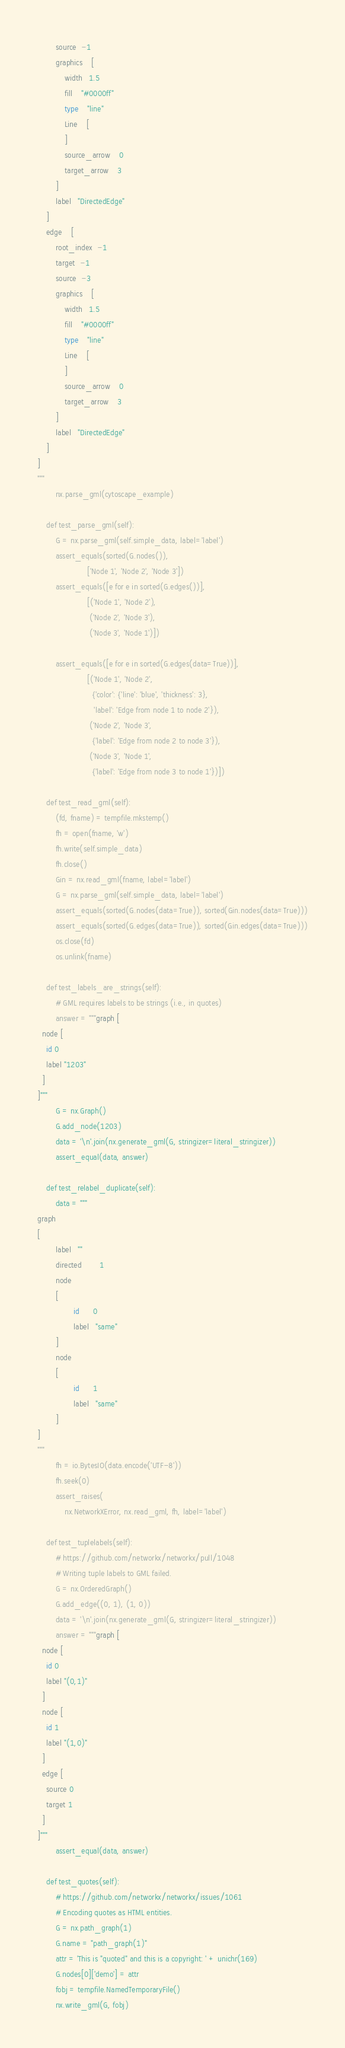<code> <loc_0><loc_0><loc_500><loc_500><_Python_>        source  -1
        graphics    [
            width   1.5
            fill    "#0000ff"
            type    "line"
            Line    [
            ]
            source_arrow    0
            target_arrow    3
        ]
        label   "DirectedEdge"
    ]
    edge    [
        root_index  -1
        target  -1
        source  -3
        graphics    [
            width   1.5
            fill    "#0000ff"
            type    "line"
            Line    [
            ]
            source_arrow    0
            target_arrow    3
        ]
        label   "DirectedEdge"
    ]
]
"""
        nx.parse_gml(cytoscape_example)

    def test_parse_gml(self):
        G = nx.parse_gml(self.simple_data, label='label')
        assert_equals(sorted(G.nodes()),
                      ['Node 1', 'Node 2', 'Node 3'])
        assert_equals([e for e in sorted(G.edges())],
                      [('Node 1', 'Node 2'),
                       ('Node 2', 'Node 3'),
                       ('Node 3', 'Node 1')])

        assert_equals([e for e in sorted(G.edges(data=True))],
                      [('Node 1', 'Node 2',
                        {'color': {'line': 'blue', 'thickness': 3},
                         'label': 'Edge from node 1 to node 2'}),
                       ('Node 2', 'Node 3',
                        {'label': 'Edge from node 2 to node 3'}),
                       ('Node 3', 'Node 1',
                        {'label': 'Edge from node 3 to node 1'})])

    def test_read_gml(self):
        (fd, fname) = tempfile.mkstemp()
        fh = open(fname, 'w')
        fh.write(self.simple_data)
        fh.close()
        Gin = nx.read_gml(fname, label='label')
        G = nx.parse_gml(self.simple_data, label='label')
        assert_equals(sorted(G.nodes(data=True)), sorted(Gin.nodes(data=True)))
        assert_equals(sorted(G.edges(data=True)), sorted(Gin.edges(data=True)))
        os.close(fd)
        os.unlink(fname)

    def test_labels_are_strings(self):
        # GML requires labels to be strings (i.e., in quotes)
        answer = """graph [
  node [
    id 0
    label "1203"
  ]
]"""
        G = nx.Graph()
        G.add_node(1203)
        data = '\n'.join(nx.generate_gml(G, stringizer=literal_stringizer))
        assert_equal(data, answer)

    def test_relabel_duplicate(self):
        data = """
graph
[
        label   ""
        directed        1
        node
        [
                id      0
                label   "same"
        ]
        node
        [
                id      1
                label   "same"
        ]
]
"""
        fh = io.BytesIO(data.encode('UTF-8'))
        fh.seek(0)
        assert_raises(
            nx.NetworkXError, nx.read_gml, fh, label='label')

    def test_tuplelabels(self):
        # https://github.com/networkx/networkx/pull/1048
        # Writing tuple labels to GML failed.
        G = nx.OrderedGraph()
        G.add_edge((0, 1), (1, 0))
        data = '\n'.join(nx.generate_gml(G, stringizer=literal_stringizer))
        answer = """graph [
  node [
    id 0
    label "(0,1)"
  ]
  node [
    id 1
    label "(1,0)"
  ]
  edge [
    source 0
    target 1
  ]
]"""
        assert_equal(data, answer)

    def test_quotes(self):
        # https://github.com/networkx/networkx/issues/1061
        # Encoding quotes as HTML entities.
        G = nx.path_graph(1)
        G.name = "path_graph(1)"
        attr = 'This is "quoted" and this is a copyright: ' + unichr(169)
        G.nodes[0]['demo'] = attr
        fobj = tempfile.NamedTemporaryFile()
        nx.write_gml(G, fobj)</code> 